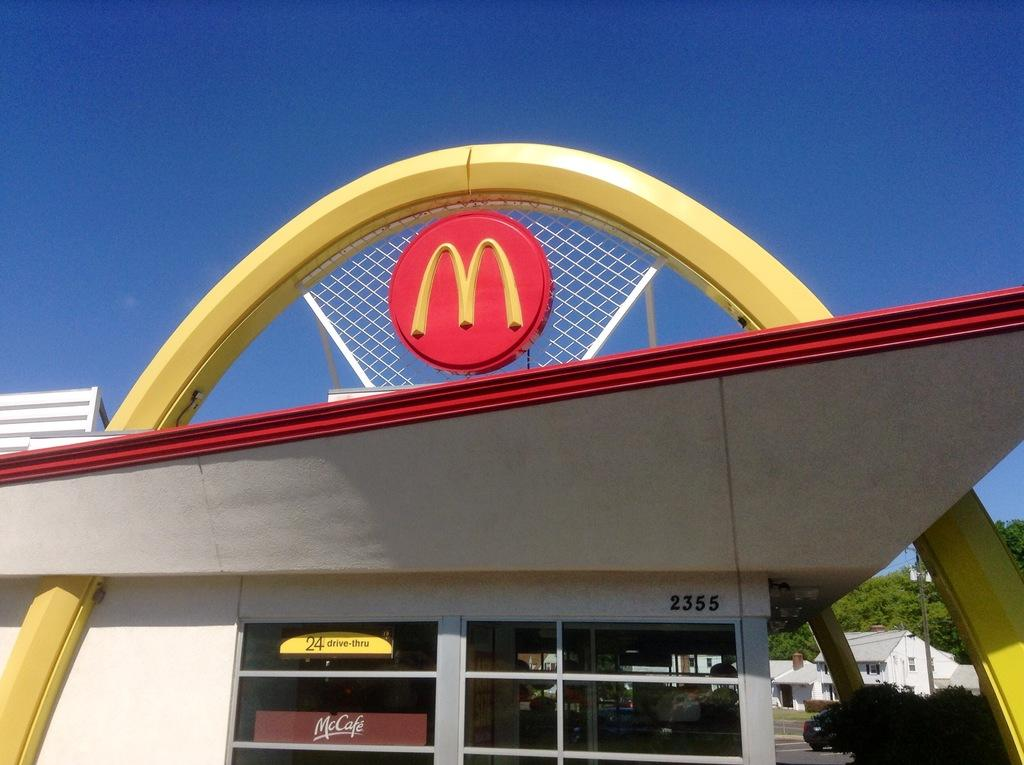What type of establishment is shown in the image? There is a store in the image. Can you describe any specific architectural details in the image? The image appears to show an architectural feature at the top. What can be seen in the sky in the image? The sky is visible in the image. What is visible in the background of the image? There are buildings and trees in the background of the image. What type of leather is being used by the laborer in the image? There is no laborer or leather present in the image. What kind of apparatus is being used by the workers in the image? There are no workers or apparatus present in the image. 